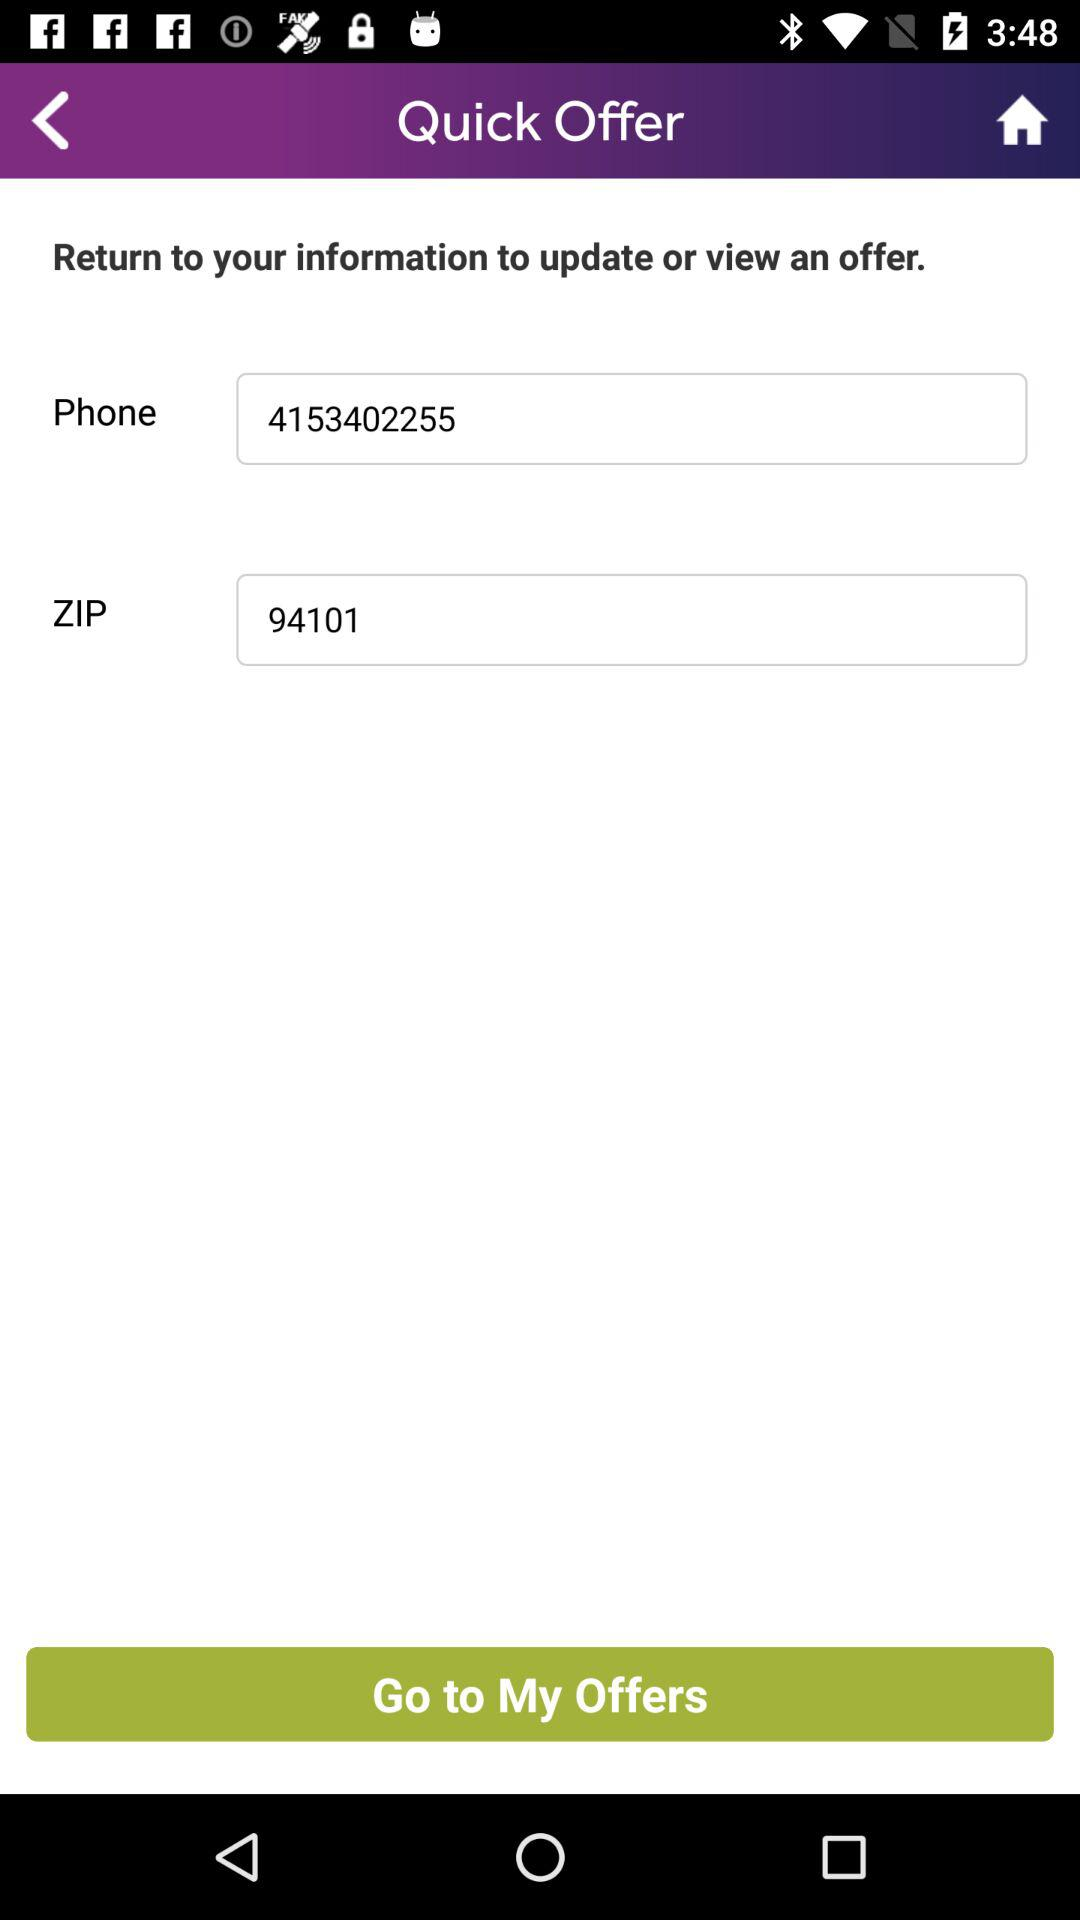What is the user's name?
When the provided information is insufficient, respond with <no answer>. <no answer> 